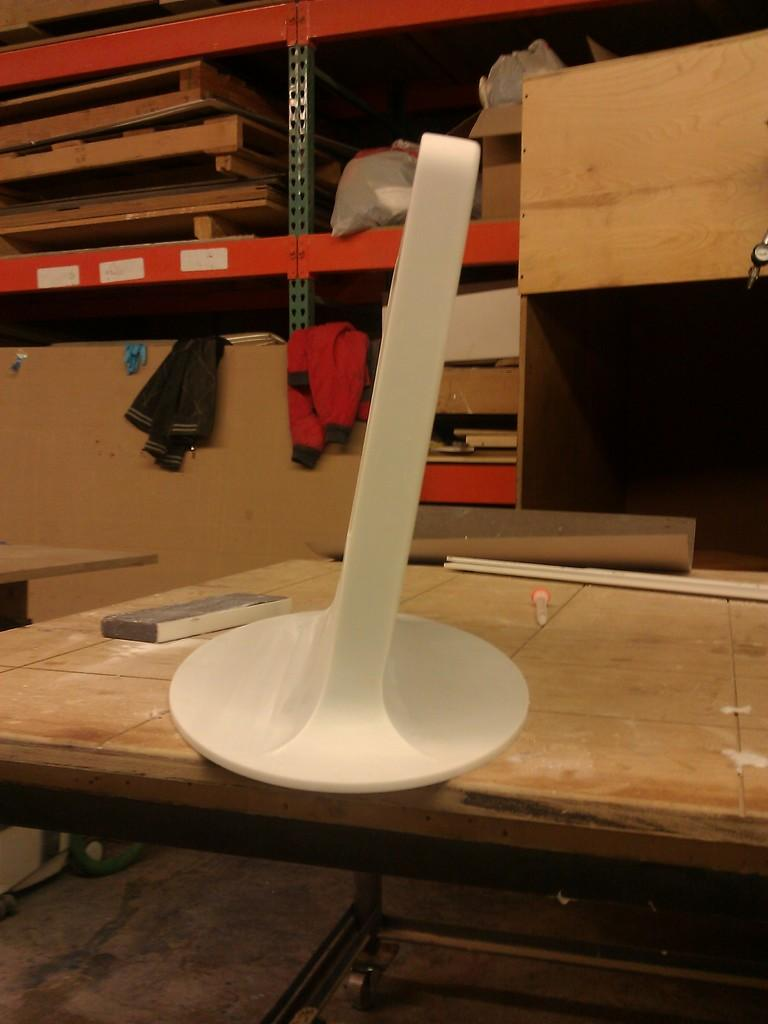What piece of furniture is present in the image? There is a table in the image. What stationary object can be seen on the table? There is a pen in the image. What can be seen in the background of the image? There are shelves, jackets, and wooden objects in the background of the image. Can you describe the other objects visible in the image? There are other objects in the image and in the background, but their specific details are not mentioned in the provided facts. What type of cheese is being marked by the tramp in the image? There is no tramp or cheese present in the image. How does the mark affect the wooden objects in the background of the image? There is no mention of a mark or its effect on the wooden objects in the image. 